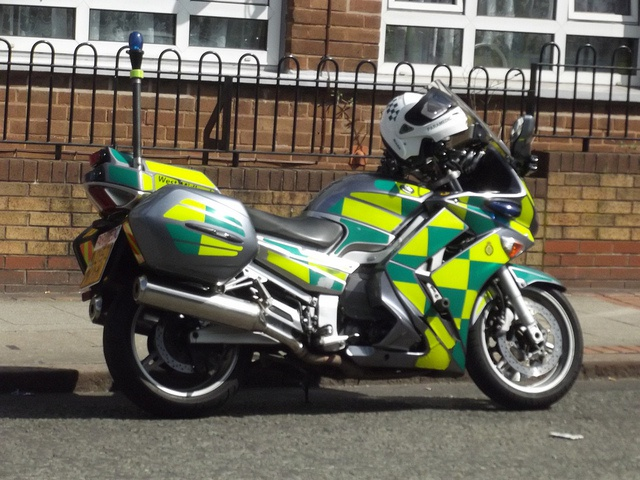Describe the objects in this image and their specific colors. I can see a motorcycle in lightgray, black, gray, white, and darkgray tones in this image. 